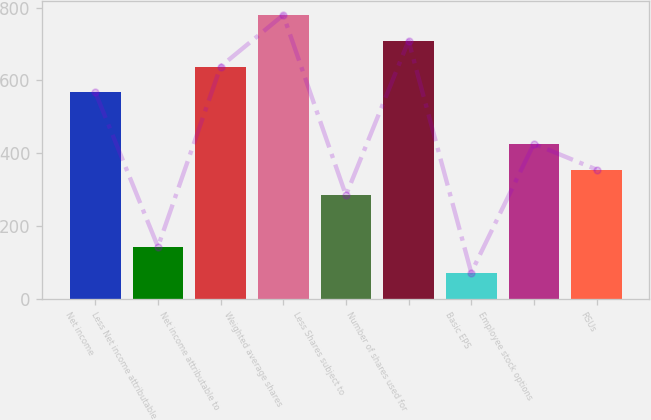Convert chart. <chart><loc_0><loc_0><loc_500><loc_500><bar_chart><fcel>Net income<fcel>Less Net income attributable<fcel>Net income attributable to<fcel>Weighted average shares<fcel>Less Shares subject to<fcel>Number of shares used for<fcel>Basic EPS<fcel>Employee stock options<fcel>RSUs<nl><fcel>567.32<fcel>142.28<fcel>638.16<fcel>779.84<fcel>283.96<fcel>709<fcel>71.44<fcel>425.64<fcel>354.8<nl></chart> 